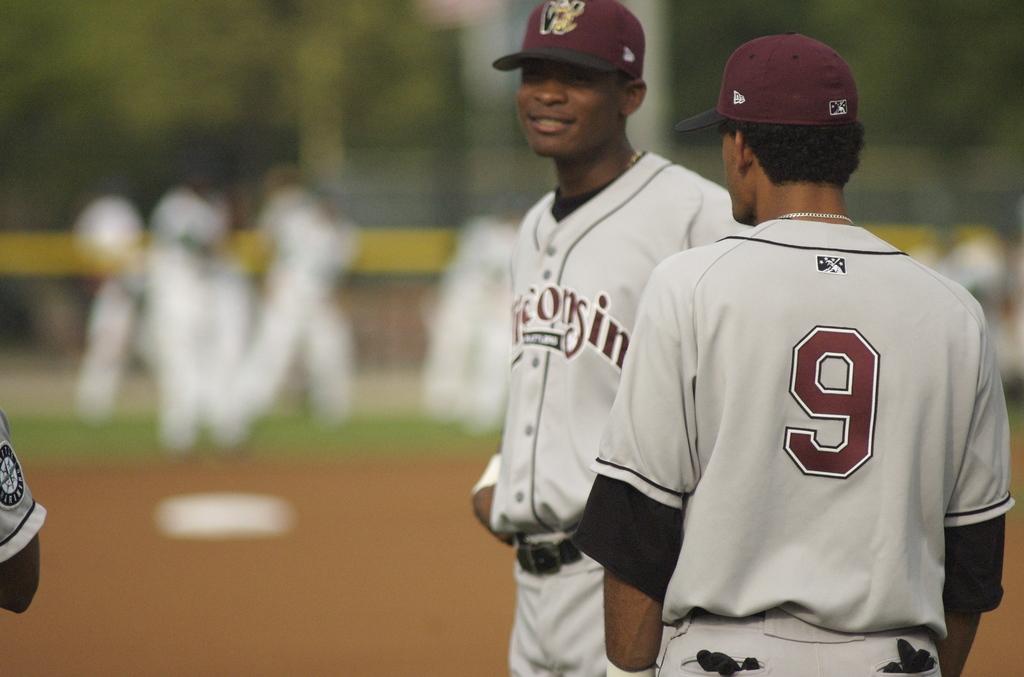What is the number on the player's jersey?
Your response must be concise. 9. What color is the number 9 on the back of his jersey?
Offer a terse response. Maroon. 